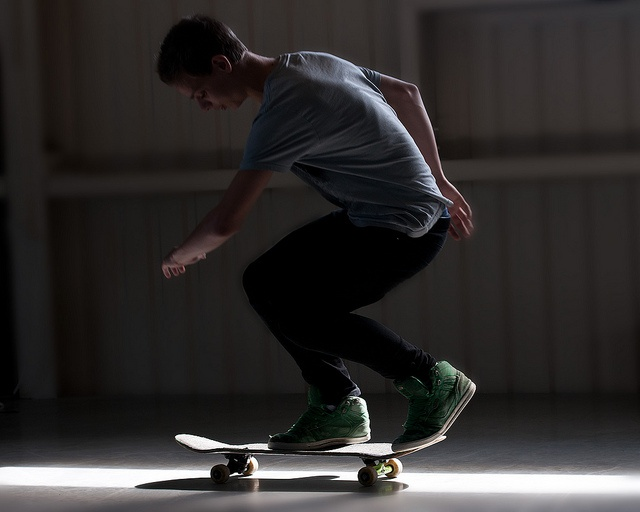Describe the objects in this image and their specific colors. I can see people in black, gray, and darkgray tones and skateboard in black, white, gray, and darkgray tones in this image. 